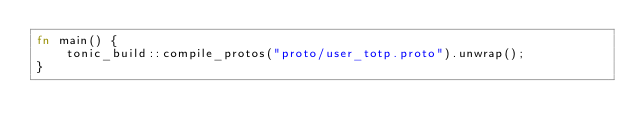<code> <loc_0><loc_0><loc_500><loc_500><_Rust_>fn main() {
    tonic_build::compile_protos("proto/user_totp.proto").unwrap();
}
</code> 